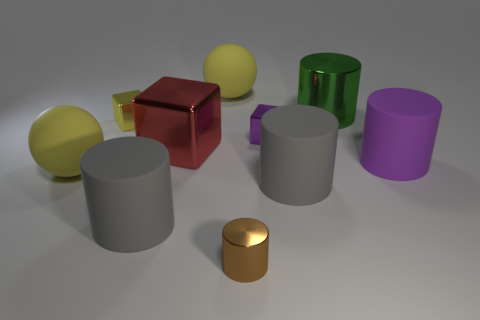How big is the gray matte cylinder that is to the left of the purple metallic cube?
Offer a terse response. Large. Do the brown metallic cylinder and the green cylinder have the same size?
Your response must be concise. No. What number of objects are small things or large yellow balls that are in front of the green thing?
Your response must be concise. 4. What is the red cube made of?
Your response must be concise. Metal. Is there anything else of the same color as the tiny cylinder?
Offer a very short reply. No. Does the large green metal thing have the same shape as the yellow metallic object?
Ensure brevity in your answer.  No. How big is the gray cylinder that is on the left side of the yellow rubber sphere that is behind the purple thing in front of the purple block?
Provide a succinct answer. Large. What number of other objects are the same material as the large green thing?
Your answer should be compact. 4. What color is the large shiny object on the right side of the small brown object?
Give a very brief answer. Green. What is the cube that is on the right side of the rubber sphere that is behind the large yellow sphere that is in front of the purple block made of?
Provide a short and direct response. Metal. 